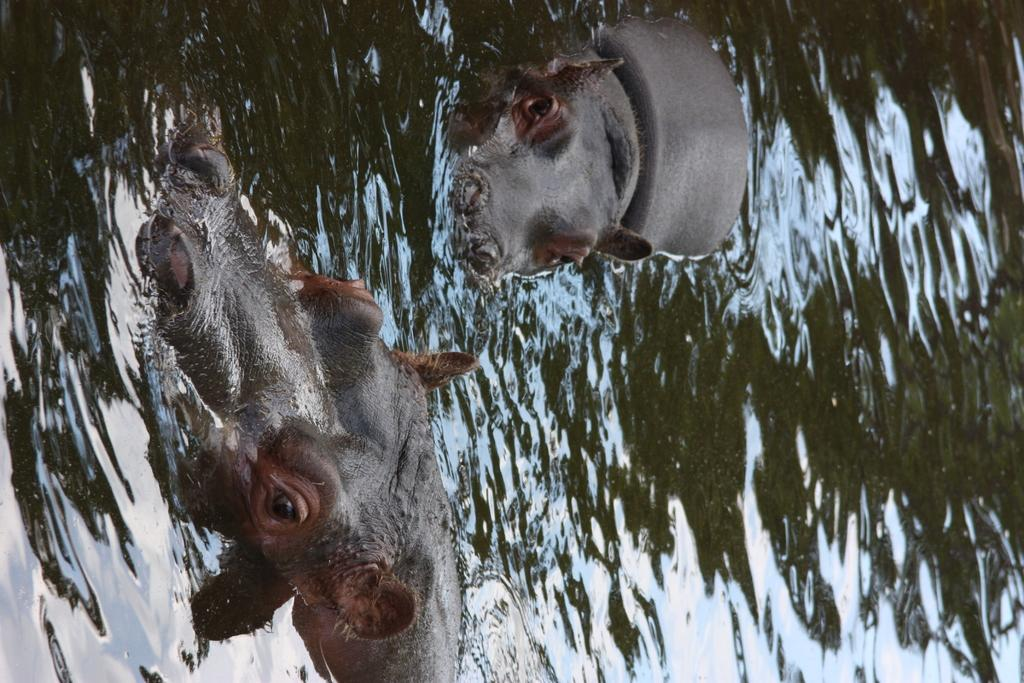What animals are present in the image? There are two rhinoceros in the image. Where are the rhinoceros located in the image? The rhinoceros are in the water. What is the income of the rhinoceros in the image? There is no information about the income of the rhinoceros in the image, as rhinoceros do not have income. 